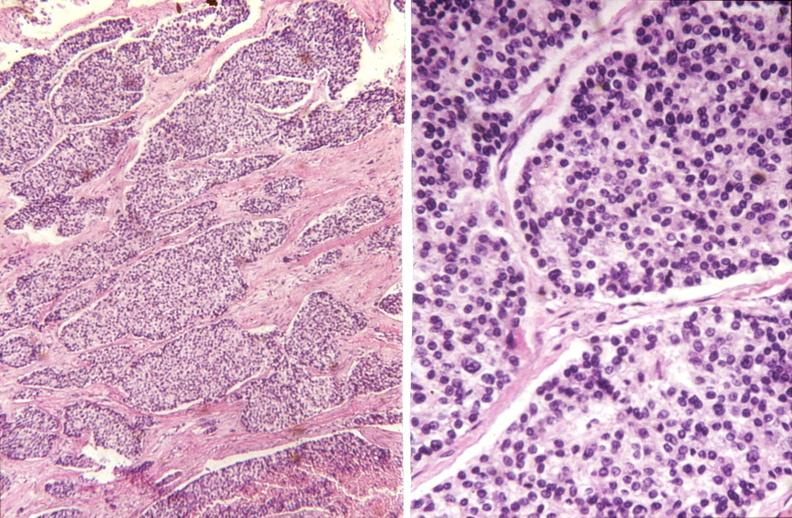s endocrine present?
Answer the question using a single word or phrase. Yes 